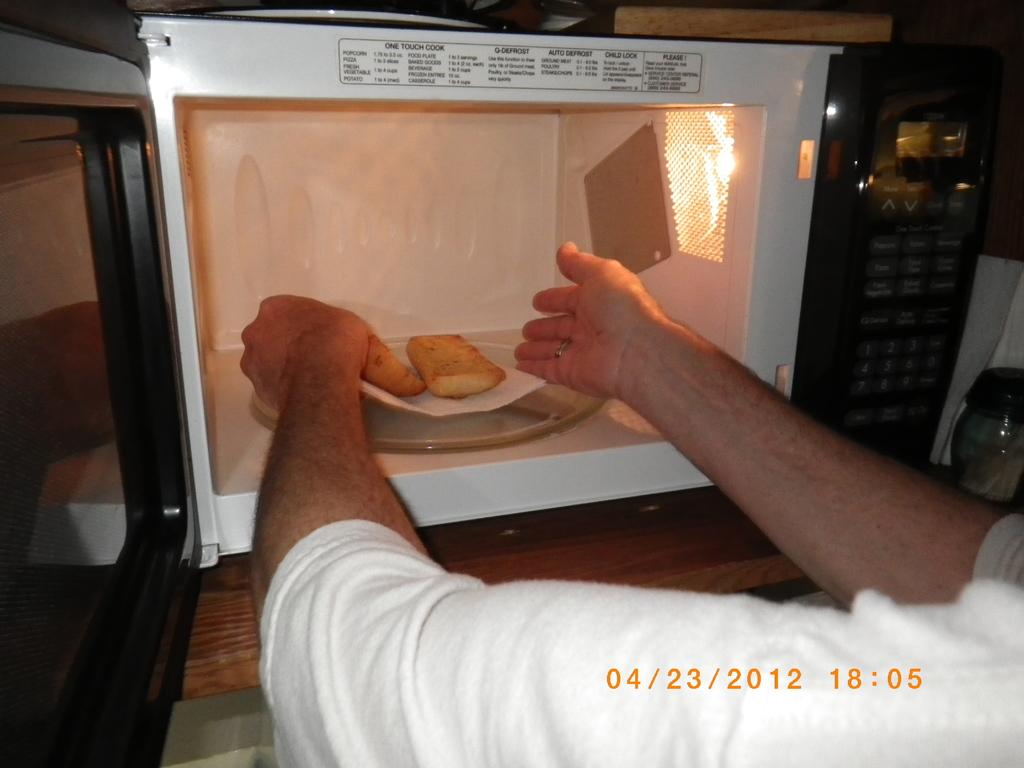What type of appliance is present in the image? There is an oven in the image. Can you describe the person in the image? The person in the image is wearing a white shirt. What type of creature is the person trying to bite in the image? There is no creature present in the image, and the person is not trying to bite anything. 